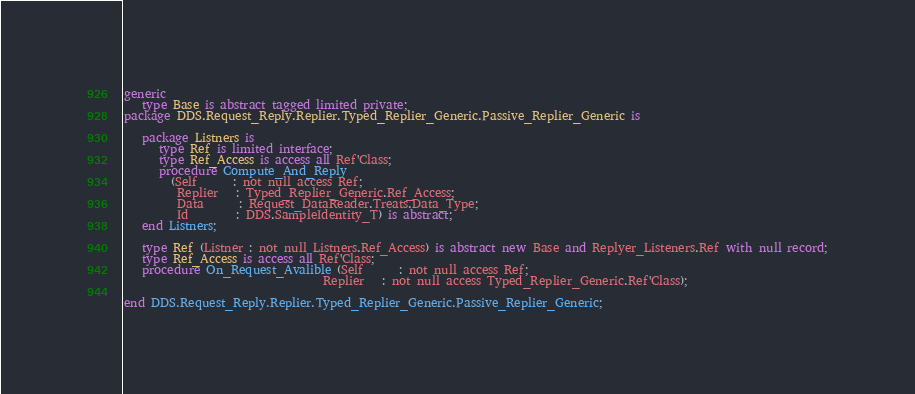Convert code to text. <code><loc_0><loc_0><loc_500><loc_500><_Ada_>generic
   type Base is abstract tagged limited private;
package DDS.Request_Reply.Replier.Typed_Replier_Generic.Passive_Replier_Generic is

   package Listners is
      type Ref is limited interface;
      type Ref_Access is access all Ref'Class;
      procedure Compute_And_Reply
        (Self      : not null access Ref;
         Replier   : Typed_Replier_Generic.Ref_Access;
         Data      : Request_DataReader.Treats.Data_Type;
         Id        : DDS.SampleIdentity_T) is abstract;
   end Listners;

   type Ref (Listner : not null Listners.Ref_Access) is abstract new Base and Replyer_Listeners.Ref with null record;
   type Ref_Access is access all Ref'Class;
   procedure On_Request_Avalible (Self      : not null access Ref;
                                  Replier   : not null access Typed_Replier_Generic.Ref'Class);

end DDS.Request_Reply.Replier.Typed_Replier_Generic.Passive_Replier_Generic;
</code> 